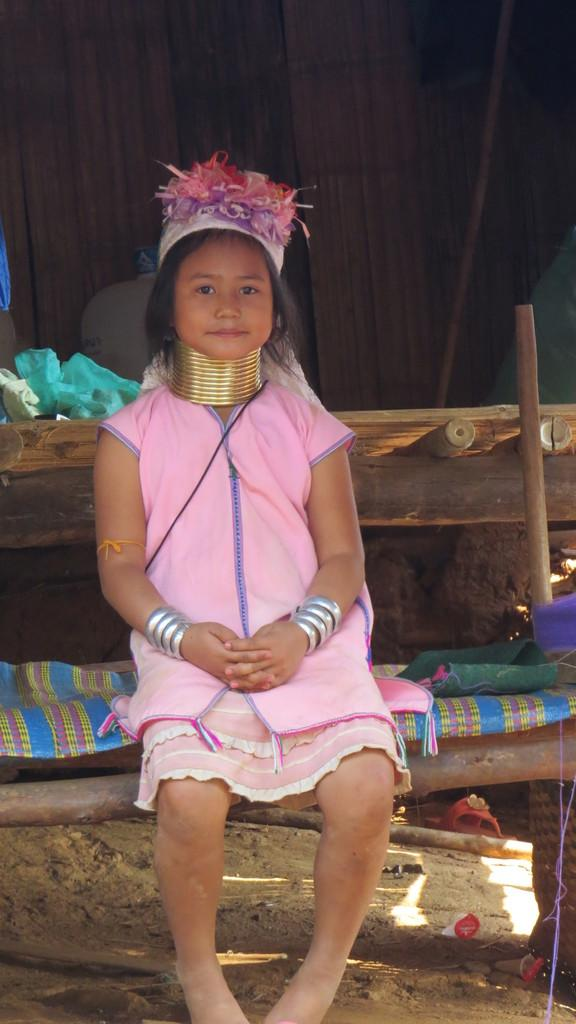Who is the main subject in the image? There is a girl in the image. What is the girl sitting on? The girl is sitting on a wooden bed. What is the girl wearing? The girl is wearing objects. What can be seen in the background of the image? There is a wooden wall in the background of the image. Can you see any potatoes in the image? There are no potatoes present in the image. Is there a curtain hanging from the wooden wall in the image? There is no curtain visible in the image; only a wooden wall is present in the background. 